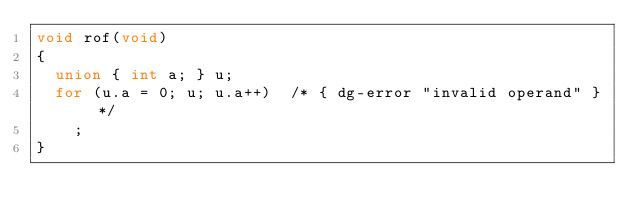<code> <loc_0><loc_0><loc_500><loc_500><_C_>void rof(void)
{
  union { int a; } u;
  for (u.a = 0; u; u.a++)  /* { dg-error "invalid operand" } */
    ;
}
</code> 